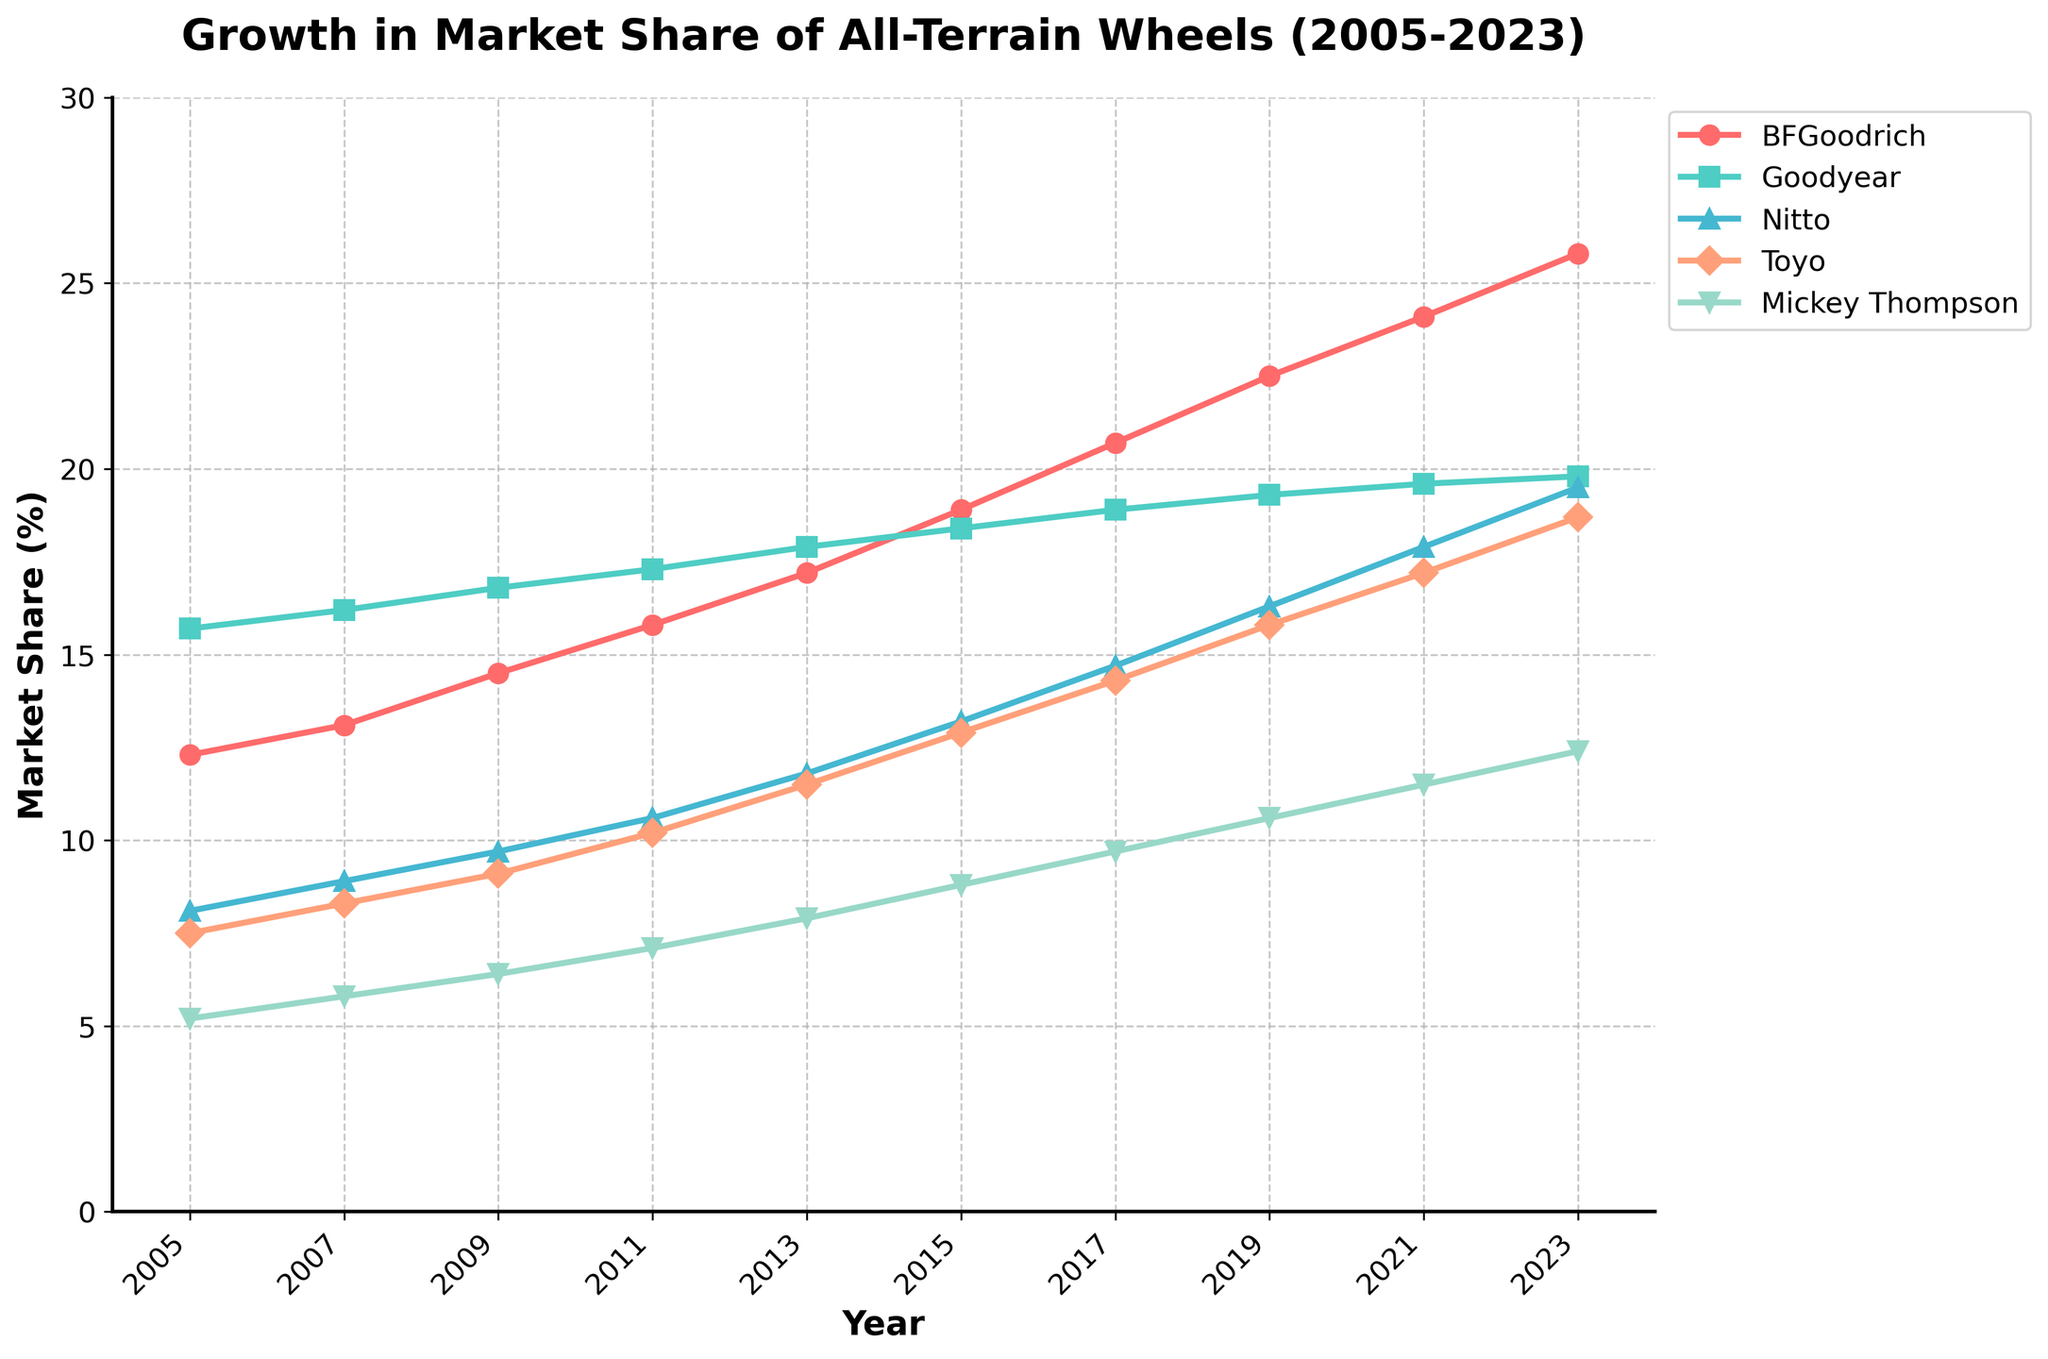When did BFGoodrich surpass 20% market share? Look at the BFGoodrich line (red) in the plot to find the point where it crosses the 20% mark. It first surpasses 20% around the year 2017.
Answer: 2017 Which brand had the highest market share in 2023? Observe the heights of the markers for 2023. BFGoodrich has the tallest marker of all.
Answer: BFGoodrich How much did Nitto’s market share increase from 2015 to 2023? Find Nitto's values in 2015 and 2023 (13.2% and 19.5%). Subtract 13.2% from 19.5% to get the increase.
Answer: 6.3% What is the total market share of BFGoodrich, Goodyear, and Nitto in 2009? Add the market shares of BFGoodrich (14.5%), Goodyear (16.8%), and Nitto (9.7%) for 2009. The sum is 14.5 + 16.8 + 9.7 = 41.
Answer: 41% Which two brands had the closest market share in 2013? Compare all pairs of values for 2013: BFGoodrich (17.2%), Goodyear (17.9%), Nitto (11.8%), Toyo (11.5%), and Mickey Thompson (7.9%). The smallest difference is between Toyo and Nitto (11.8 - 11.5 = 0.3).
Answer: Toyo and Nitto What’s the average market share of Toyo from 2005 to 2023? Add Toyo's market shares from 2005 to 2023 (7.5%, 8.3%, 9.1%, 10.2%, 11.5%, 12.9%, 14.3%, 15.8%, 17.2%, 18.7%). Divide by the number of years (10). The sum is 125.5, so 125.5 / 10 = 12.55.
Answer: 12.55% By how much did Mickey Thompson’s market share grow between 2005 and 2023? Find Mickey Thompson's values in 2005 and 2023 (5.2% and 12.4%). Subtract 5.2% from 12.4% to get the growth.
Answer: 7.2% Between which years did BFGoodrich experience the highest growth in market share? Look for the steepest slope in the BFGoodrich line. The sharpest increase is between 2021 (24.1%) and 2023 (25.8%). The difference is 1.7%.
Answer: 2021-2023 